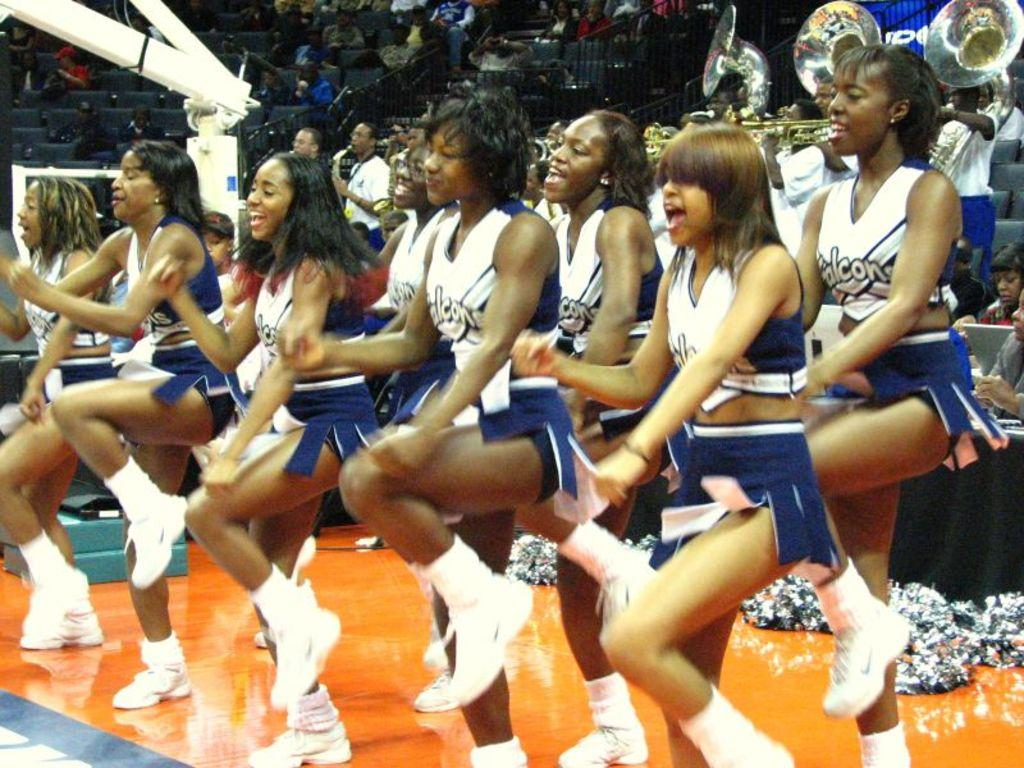<image>
Give a short and clear explanation of the subsequent image. The Falcons cheerleading squad performs on the sidelines. 